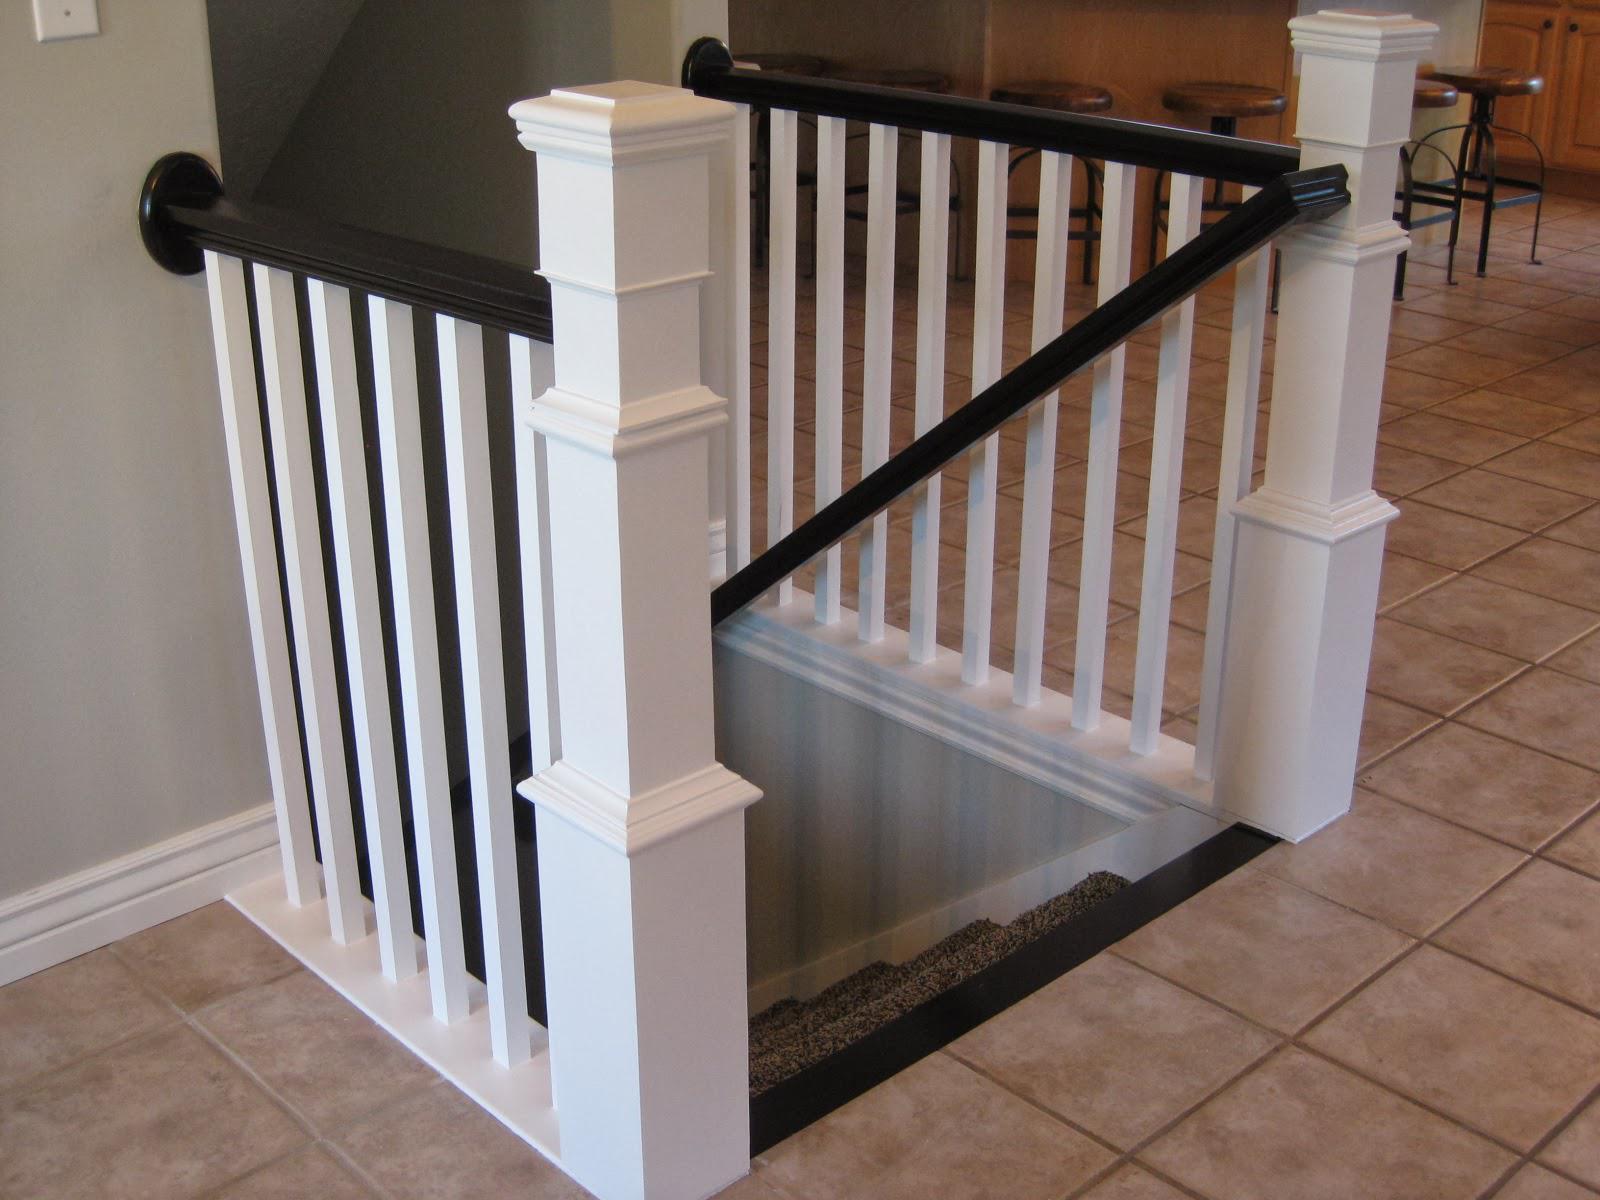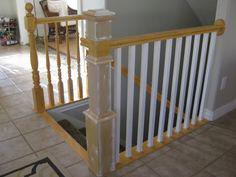The first image is the image on the left, the second image is the image on the right. Analyze the images presented: Is the assertion "Each image shows at least one square corner post and straight white bars flanking a descending flight of stairs." valid? Answer yes or no. Yes. 